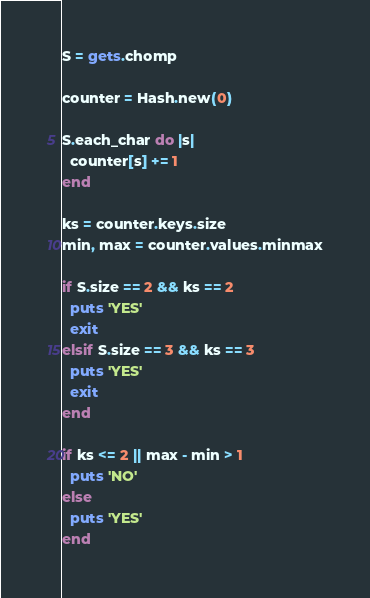<code> <loc_0><loc_0><loc_500><loc_500><_Ruby_>S = gets.chomp

counter = Hash.new(0)

S.each_char do |s|
  counter[s] += 1
end

ks = counter.keys.size
min, max = counter.values.minmax

if S.size == 2 && ks == 2
  puts 'YES'
  exit
elsif S.size == 3 && ks == 3
  puts 'YES'
  exit
end

if ks <= 2 || max - min > 1
  puts 'NO'
else
  puts 'YES'
end
</code> 